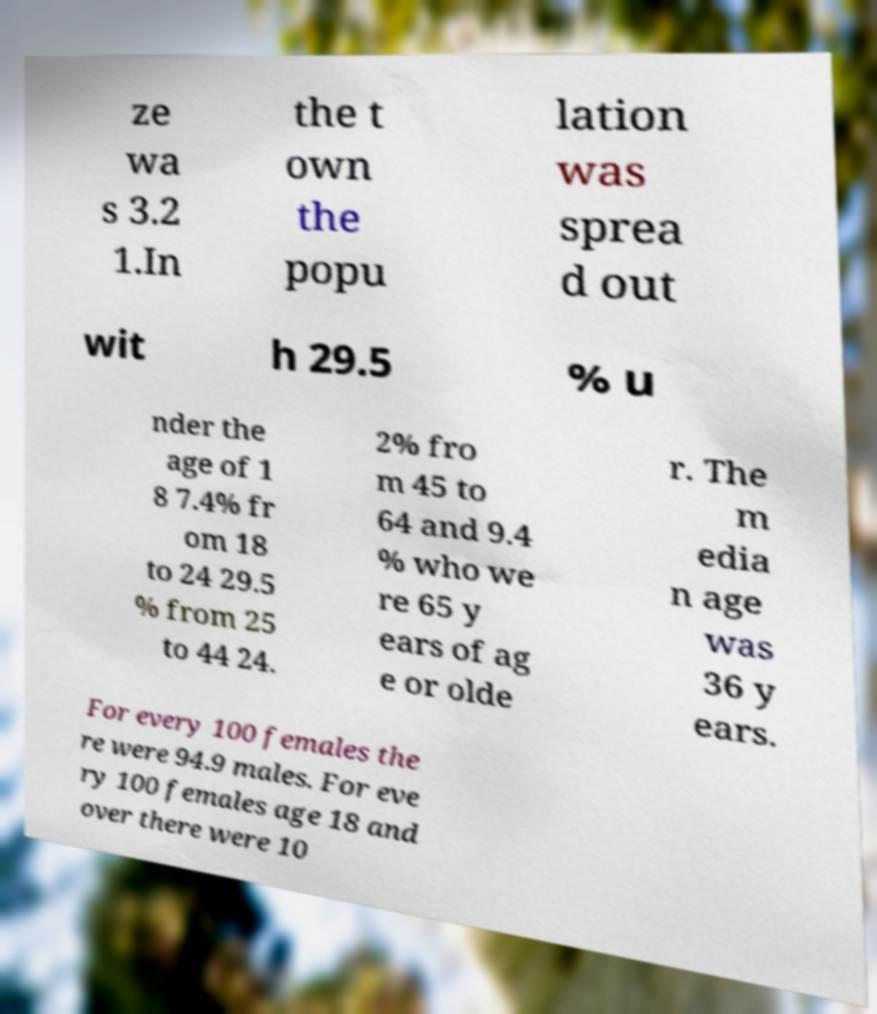Could you assist in decoding the text presented in this image and type it out clearly? ze wa s 3.2 1.In the t own the popu lation was sprea d out wit h 29.5 % u nder the age of 1 8 7.4% fr om 18 to 24 29.5 % from 25 to 44 24. 2% fro m 45 to 64 and 9.4 % who we re 65 y ears of ag e or olde r. The m edia n age was 36 y ears. For every 100 females the re were 94.9 males. For eve ry 100 females age 18 and over there were 10 